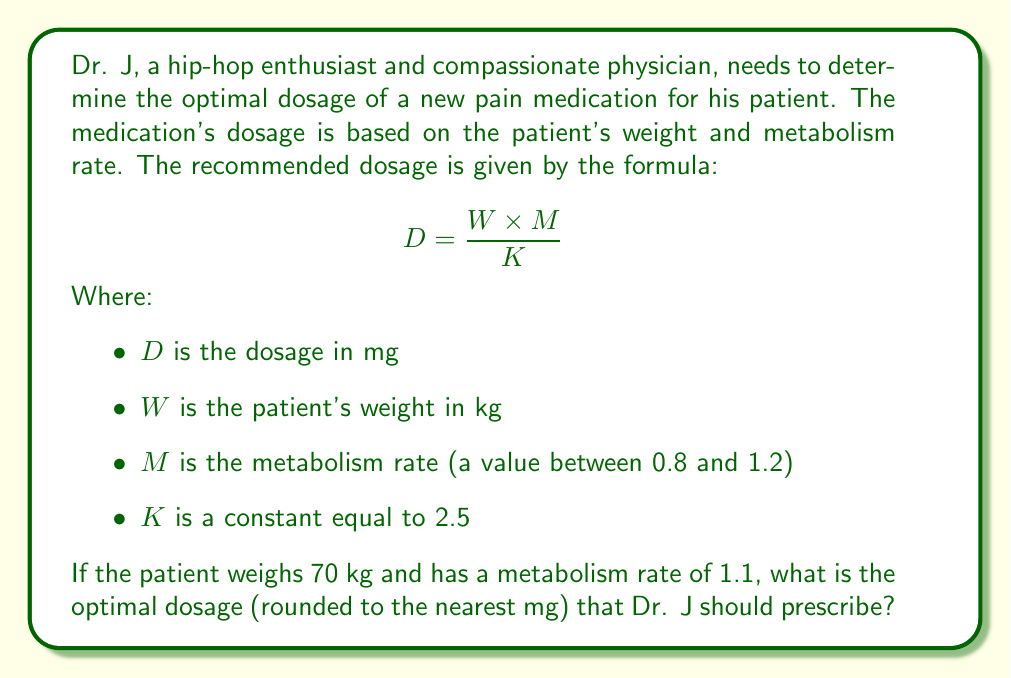Can you answer this question? To solve this problem, we'll follow these steps:

1. Identify the given values:
   $W = 70$ kg (patient's weight)
   $M = 1.1$ (metabolism rate)
   $K = 2.5$ (constant)

2. Substitute these values into the dosage formula:

   $$ D = \frac{W \times M}{K} $$
   $$ D = \frac{70 \times 1.1}{2.5} $$

3. Perform the calculation:
   $$ D = \frac{77}{2.5} = 30.8 \text{ mg} $$

4. Round the result to the nearest mg:
   $30.8 \text{ mg} \approx 31 \text{ mg}$

Therefore, the optimal dosage that Dr. J should prescribe is 31 mg.

This calculation takes into account both the patient's weight and their metabolism rate, ensuring a personalized and effective dosage. The higher metabolism rate (1.1) indicates that the patient may process the medication more quickly, thus requiring a slightly higher dose than someone with an average metabolism rate (1.0).
Answer: 31 mg 